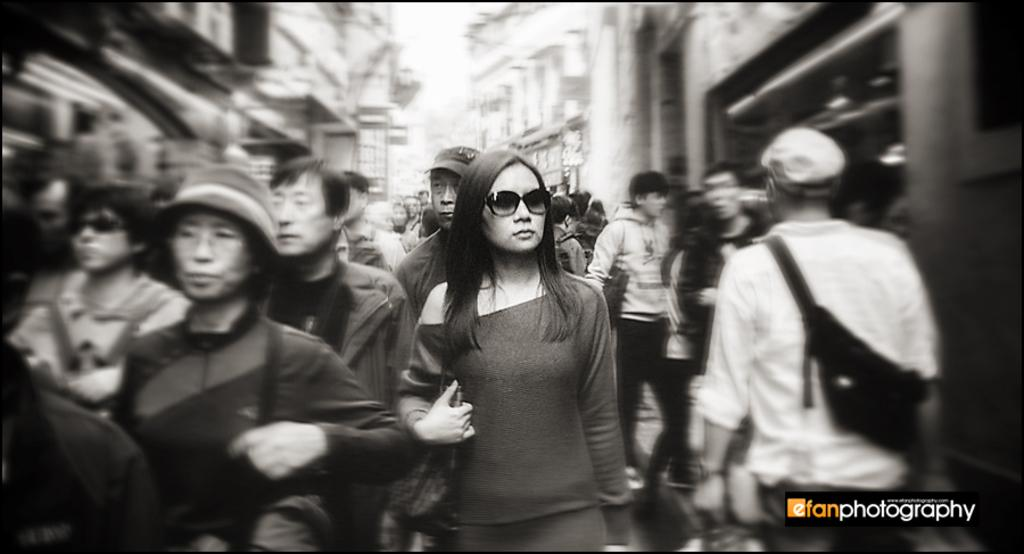What is the color scheme of the image? The image is black and white. What can be seen in the image? There are persons in the image. What is visible in the background of the image? There are buildings in the background of the image. What type of knot is being tied by the person in the image? There is no knot-tying activity visible in the image. Can you see a pail being used by any of the persons in the image? There is no pail present in the image. 